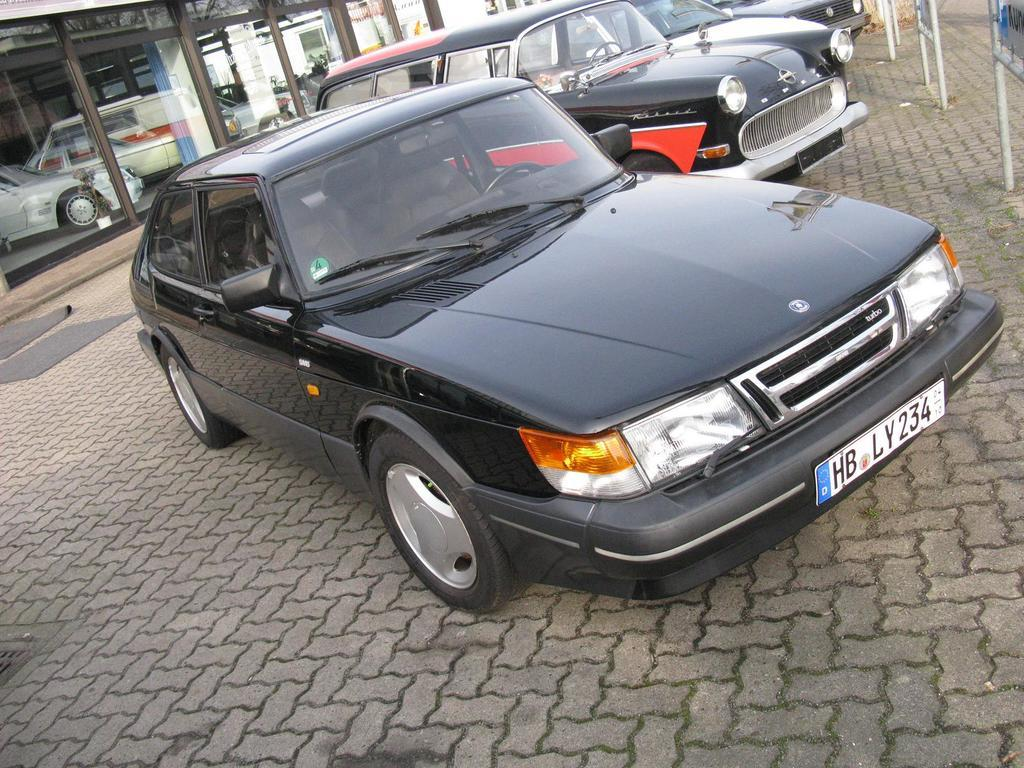What is blocking the path in the image? There are cars parked on the path in the image. What type of flooring can be seen in the image? Mats are visible in the image. What type of establishment is featured in the image? There is a car showroom in the image. What is located on the right side of the image? Boards are present on the right side of the image. What is the belief of the cars parked on the path in the image? The cars parked on the path do not have beliefs, as they are inanimate objects. How does the digestion of the cars parked on the path in the image work? Cars do not have digestive systems, as they are not living organisms. 